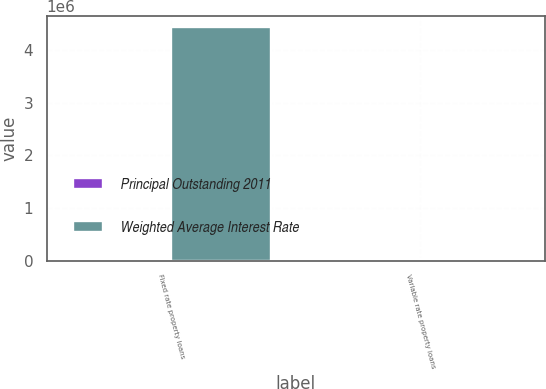Convert chart to OTSL. <chart><loc_0><loc_0><loc_500><loc_500><stacked_bar_chart><ecel><fcel>Fixed rate property loans<fcel>Variable rate property loans<nl><fcel>Principal Outstanding 2011<fcel>5.58<fcel>2.93<nl><fcel>Weighted Average Interest Rate<fcel>4.43436e+06<fcel>24038<nl></chart> 